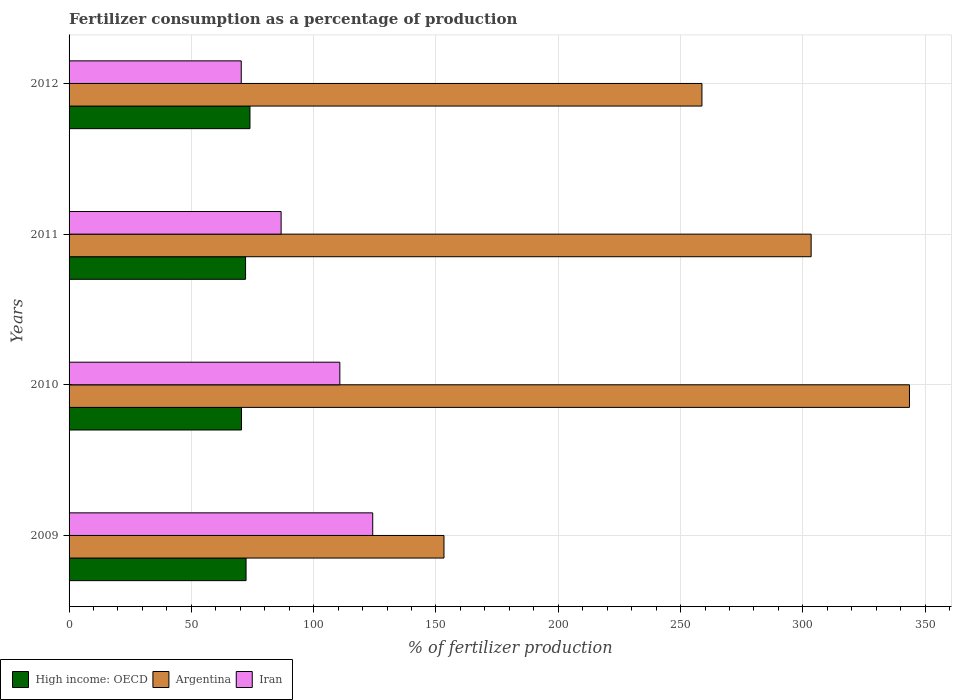How many different coloured bars are there?
Your response must be concise. 3. Are the number of bars per tick equal to the number of legend labels?
Offer a terse response. Yes. Are the number of bars on each tick of the Y-axis equal?
Ensure brevity in your answer.  Yes. How many bars are there on the 3rd tick from the bottom?
Your response must be concise. 3. What is the label of the 3rd group of bars from the top?
Provide a succinct answer. 2010. In how many cases, is the number of bars for a given year not equal to the number of legend labels?
Offer a very short reply. 0. What is the percentage of fertilizers consumed in Iran in 2010?
Offer a very short reply. 110.7. Across all years, what is the maximum percentage of fertilizers consumed in High income: OECD?
Your answer should be very brief. 73.96. Across all years, what is the minimum percentage of fertilizers consumed in Argentina?
Keep it short and to the point. 153.28. In which year was the percentage of fertilizers consumed in Argentina maximum?
Your answer should be compact. 2010. What is the total percentage of fertilizers consumed in High income: OECD in the graph?
Provide a succinct answer. 288.98. What is the difference between the percentage of fertilizers consumed in Argentina in 2009 and that in 2010?
Your response must be concise. -190.31. What is the difference between the percentage of fertilizers consumed in Argentina in 2010 and the percentage of fertilizers consumed in High income: OECD in 2009?
Provide a succinct answer. 271.23. What is the average percentage of fertilizers consumed in Iran per year?
Provide a short and direct response. 97.98. In the year 2011, what is the difference between the percentage of fertilizers consumed in Argentina and percentage of fertilizers consumed in High income: OECD?
Provide a short and direct response. 231.23. In how many years, is the percentage of fertilizers consumed in Argentina greater than 240 %?
Your response must be concise. 3. What is the ratio of the percentage of fertilizers consumed in Argentina in 2009 to that in 2010?
Offer a terse response. 0.45. Is the percentage of fertilizers consumed in High income: OECD in 2010 less than that in 2012?
Offer a very short reply. Yes. What is the difference between the highest and the second highest percentage of fertilizers consumed in Argentina?
Keep it short and to the point. 40.2. What is the difference between the highest and the lowest percentage of fertilizers consumed in Argentina?
Your answer should be compact. 190.31. In how many years, is the percentage of fertilizers consumed in Argentina greater than the average percentage of fertilizers consumed in Argentina taken over all years?
Give a very brief answer. 2. Is the sum of the percentage of fertilizers consumed in Iran in 2009 and 2010 greater than the maximum percentage of fertilizers consumed in High income: OECD across all years?
Your response must be concise. Yes. What does the 2nd bar from the top in 2012 represents?
Provide a short and direct response. Argentina. What does the 1st bar from the bottom in 2010 represents?
Give a very brief answer. High income: OECD. Is it the case that in every year, the sum of the percentage of fertilizers consumed in Iran and percentage of fertilizers consumed in Argentina is greater than the percentage of fertilizers consumed in High income: OECD?
Provide a succinct answer. Yes. How are the legend labels stacked?
Offer a terse response. Horizontal. What is the title of the graph?
Offer a terse response. Fertilizer consumption as a percentage of production. Does "Isle of Man" appear as one of the legend labels in the graph?
Offer a terse response. No. What is the label or title of the X-axis?
Make the answer very short. % of fertilizer production. What is the label or title of the Y-axis?
Offer a terse response. Years. What is the % of fertilizer production in High income: OECD in 2009?
Provide a succinct answer. 72.36. What is the % of fertilizer production in Argentina in 2009?
Keep it short and to the point. 153.28. What is the % of fertilizer production of Iran in 2009?
Keep it short and to the point. 124.14. What is the % of fertilizer production of High income: OECD in 2010?
Offer a terse response. 70.5. What is the % of fertilizer production of Argentina in 2010?
Ensure brevity in your answer.  343.59. What is the % of fertilizer production in Iran in 2010?
Your response must be concise. 110.7. What is the % of fertilizer production in High income: OECD in 2011?
Make the answer very short. 72.16. What is the % of fertilizer production in Argentina in 2011?
Keep it short and to the point. 303.39. What is the % of fertilizer production in Iran in 2011?
Provide a succinct answer. 86.7. What is the % of fertilizer production of High income: OECD in 2012?
Provide a succinct answer. 73.96. What is the % of fertilizer production in Argentina in 2012?
Your answer should be compact. 258.74. What is the % of fertilizer production in Iran in 2012?
Offer a very short reply. 70.39. Across all years, what is the maximum % of fertilizer production in High income: OECD?
Give a very brief answer. 73.96. Across all years, what is the maximum % of fertilizer production in Argentina?
Keep it short and to the point. 343.59. Across all years, what is the maximum % of fertilizer production in Iran?
Offer a terse response. 124.14. Across all years, what is the minimum % of fertilizer production in High income: OECD?
Provide a succinct answer. 70.5. Across all years, what is the minimum % of fertilizer production of Argentina?
Make the answer very short. 153.28. Across all years, what is the minimum % of fertilizer production of Iran?
Your response must be concise. 70.39. What is the total % of fertilizer production of High income: OECD in the graph?
Make the answer very short. 288.98. What is the total % of fertilizer production of Argentina in the graph?
Provide a short and direct response. 1059. What is the total % of fertilizer production of Iran in the graph?
Keep it short and to the point. 391.94. What is the difference between the % of fertilizer production of High income: OECD in 2009 and that in 2010?
Provide a short and direct response. 1.86. What is the difference between the % of fertilizer production of Argentina in 2009 and that in 2010?
Your answer should be very brief. -190.31. What is the difference between the % of fertilizer production in Iran in 2009 and that in 2010?
Offer a very short reply. 13.44. What is the difference between the % of fertilizer production in High income: OECD in 2009 and that in 2011?
Your answer should be compact. 0.2. What is the difference between the % of fertilizer production of Argentina in 2009 and that in 2011?
Provide a succinct answer. -150.11. What is the difference between the % of fertilizer production of Iran in 2009 and that in 2011?
Give a very brief answer. 37.44. What is the difference between the % of fertilizer production in High income: OECD in 2009 and that in 2012?
Offer a very short reply. -1.6. What is the difference between the % of fertilizer production of Argentina in 2009 and that in 2012?
Offer a terse response. -105.46. What is the difference between the % of fertilizer production of Iran in 2009 and that in 2012?
Your answer should be very brief. 53.75. What is the difference between the % of fertilizer production of High income: OECD in 2010 and that in 2011?
Your response must be concise. -1.66. What is the difference between the % of fertilizer production of Argentina in 2010 and that in 2011?
Ensure brevity in your answer.  40.2. What is the difference between the % of fertilizer production in Iran in 2010 and that in 2011?
Your answer should be very brief. 24.01. What is the difference between the % of fertilizer production in High income: OECD in 2010 and that in 2012?
Make the answer very short. -3.46. What is the difference between the % of fertilizer production of Argentina in 2010 and that in 2012?
Provide a succinct answer. 84.85. What is the difference between the % of fertilizer production of Iran in 2010 and that in 2012?
Provide a succinct answer. 40.31. What is the difference between the % of fertilizer production of High income: OECD in 2011 and that in 2012?
Keep it short and to the point. -1.8. What is the difference between the % of fertilizer production in Argentina in 2011 and that in 2012?
Your response must be concise. 44.65. What is the difference between the % of fertilizer production in Iran in 2011 and that in 2012?
Give a very brief answer. 16.3. What is the difference between the % of fertilizer production in High income: OECD in 2009 and the % of fertilizer production in Argentina in 2010?
Your answer should be compact. -271.23. What is the difference between the % of fertilizer production in High income: OECD in 2009 and the % of fertilizer production in Iran in 2010?
Offer a terse response. -38.34. What is the difference between the % of fertilizer production in Argentina in 2009 and the % of fertilizer production in Iran in 2010?
Provide a succinct answer. 42.57. What is the difference between the % of fertilizer production of High income: OECD in 2009 and the % of fertilizer production of Argentina in 2011?
Your answer should be very brief. -231.03. What is the difference between the % of fertilizer production in High income: OECD in 2009 and the % of fertilizer production in Iran in 2011?
Your answer should be compact. -14.34. What is the difference between the % of fertilizer production in Argentina in 2009 and the % of fertilizer production in Iran in 2011?
Offer a terse response. 66.58. What is the difference between the % of fertilizer production in High income: OECD in 2009 and the % of fertilizer production in Argentina in 2012?
Provide a succinct answer. -186.38. What is the difference between the % of fertilizer production of High income: OECD in 2009 and the % of fertilizer production of Iran in 2012?
Your response must be concise. 1.97. What is the difference between the % of fertilizer production of Argentina in 2009 and the % of fertilizer production of Iran in 2012?
Offer a terse response. 82.88. What is the difference between the % of fertilizer production of High income: OECD in 2010 and the % of fertilizer production of Argentina in 2011?
Offer a terse response. -232.89. What is the difference between the % of fertilizer production of High income: OECD in 2010 and the % of fertilizer production of Iran in 2011?
Ensure brevity in your answer.  -16.2. What is the difference between the % of fertilizer production in Argentina in 2010 and the % of fertilizer production in Iran in 2011?
Make the answer very short. 256.89. What is the difference between the % of fertilizer production of High income: OECD in 2010 and the % of fertilizer production of Argentina in 2012?
Make the answer very short. -188.24. What is the difference between the % of fertilizer production in High income: OECD in 2010 and the % of fertilizer production in Iran in 2012?
Provide a short and direct response. 0.1. What is the difference between the % of fertilizer production of Argentina in 2010 and the % of fertilizer production of Iran in 2012?
Make the answer very short. 273.19. What is the difference between the % of fertilizer production of High income: OECD in 2011 and the % of fertilizer production of Argentina in 2012?
Provide a short and direct response. -186.58. What is the difference between the % of fertilizer production of High income: OECD in 2011 and the % of fertilizer production of Iran in 2012?
Provide a succinct answer. 1.77. What is the difference between the % of fertilizer production in Argentina in 2011 and the % of fertilizer production in Iran in 2012?
Your response must be concise. 233. What is the average % of fertilizer production in High income: OECD per year?
Make the answer very short. 72.24. What is the average % of fertilizer production in Argentina per year?
Ensure brevity in your answer.  264.75. What is the average % of fertilizer production in Iran per year?
Ensure brevity in your answer.  97.98. In the year 2009, what is the difference between the % of fertilizer production of High income: OECD and % of fertilizer production of Argentina?
Offer a terse response. -80.92. In the year 2009, what is the difference between the % of fertilizer production of High income: OECD and % of fertilizer production of Iran?
Provide a succinct answer. -51.78. In the year 2009, what is the difference between the % of fertilizer production of Argentina and % of fertilizer production of Iran?
Offer a terse response. 29.14. In the year 2010, what is the difference between the % of fertilizer production in High income: OECD and % of fertilizer production in Argentina?
Keep it short and to the point. -273.09. In the year 2010, what is the difference between the % of fertilizer production in High income: OECD and % of fertilizer production in Iran?
Offer a very short reply. -40.21. In the year 2010, what is the difference between the % of fertilizer production in Argentina and % of fertilizer production in Iran?
Your response must be concise. 232.88. In the year 2011, what is the difference between the % of fertilizer production of High income: OECD and % of fertilizer production of Argentina?
Keep it short and to the point. -231.23. In the year 2011, what is the difference between the % of fertilizer production of High income: OECD and % of fertilizer production of Iran?
Your answer should be compact. -14.54. In the year 2011, what is the difference between the % of fertilizer production of Argentina and % of fertilizer production of Iran?
Ensure brevity in your answer.  216.69. In the year 2012, what is the difference between the % of fertilizer production of High income: OECD and % of fertilizer production of Argentina?
Make the answer very short. -184.78. In the year 2012, what is the difference between the % of fertilizer production of High income: OECD and % of fertilizer production of Iran?
Make the answer very short. 3.56. In the year 2012, what is the difference between the % of fertilizer production in Argentina and % of fertilizer production in Iran?
Your answer should be compact. 188.35. What is the ratio of the % of fertilizer production in High income: OECD in 2009 to that in 2010?
Offer a terse response. 1.03. What is the ratio of the % of fertilizer production of Argentina in 2009 to that in 2010?
Give a very brief answer. 0.45. What is the ratio of the % of fertilizer production in Iran in 2009 to that in 2010?
Offer a very short reply. 1.12. What is the ratio of the % of fertilizer production in Argentina in 2009 to that in 2011?
Your response must be concise. 0.51. What is the ratio of the % of fertilizer production in Iran in 2009 to that in 2011?
Provide a succinct answer. 1.43. What is the ratio of the % of fertilizer production in High income: OECD in 2009 to that in 2012?
Offer a very short reply. 0.98. What is the ratio of the % of fertilizer production in Argentina in 2009 to that in 2012?
Ensure brevity in your answer.  0.59. What is the ratio of the % of fertilizer production of Iran in 2009 to that in 2012?
Provide a short and direct response. 1.76. What is the ratio of the % of fertilizer production of High income: OECD in 2010 to that in 2011?
Offer a very short reply. 0.98. What is the ratio of the % of fertilizer production in Argentina in 2010 to that in 2011?
Keep it short and to the point. 1.13. What is the ratio of the % of fertilizer production of Iran in 2010 to that in 2011?
Your answer should be very brief. 1.28. What is the ratio of the % of fertilizer production in High income: OECD in 2010 to that in 2012?
Keep it short and to the point. 0.95. What is the ratio of the % of fertilizer production in Argentina in 2010 to that in 2012?
Keep it short and to the point. 1.33. What is the ratio of the % of fertilizer production of Iran in 2010 to that in 2012?
Make the answer very short. 1.57. What is the ratio of the % of fertilizer production of High income: OECD in 2011 to that in 2012?
Offer a terse response. 0.98. What is the ratio of the % of fertilizer production in Argentina in 2011 to that in 2012?
Ensure brevity in your answer.  1.17. What is the ratio of the % of fertilizer production of Iran in 2011 to that in 2012?
Provide a short and direct response. 1.23. What is the difference between the highest and the second highest % of fertilizer production in High income: OECD?
Provide a short and direct response. 1.6. What is the difference between the highest and the second highest % of fertilizer production in Argentina?
Your answer should be very brief. 40.2. What is the difference between the highest and the second highest % of fertilizer production in Iran?
Offer a terse response. 13.44. What is the difference between the highest and the lowest % of fertilizer production of High income: OECD?
Give a very brief answer. 3.46. What is the difference between the highest and the lowest % of fertilizer production of Argentina?
Make the answer very short. 190.31. What is the difference between the highest and the lowest % of fertilizer production in Iran?
Make the answer very short. 53.75. 